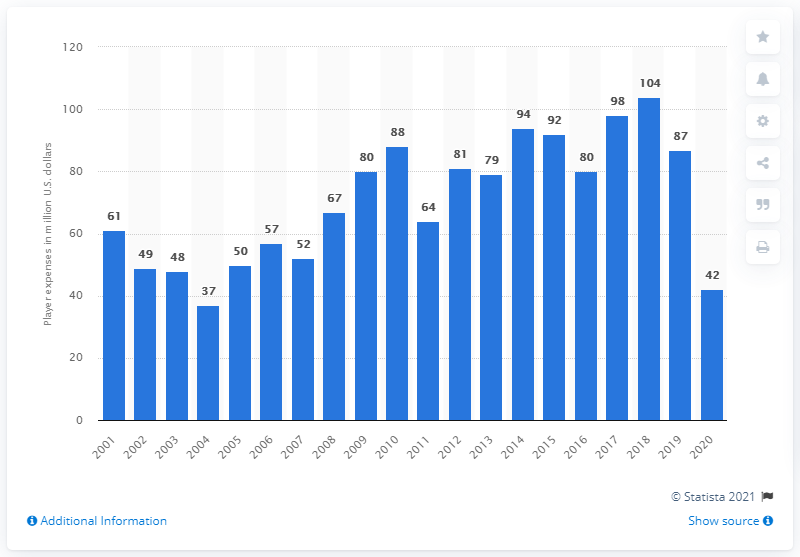Mention a couple of crucial points in this snapshot. I'm sorry, but I'm not sure what you are asking. Could you please provide more context or clarify your question? 